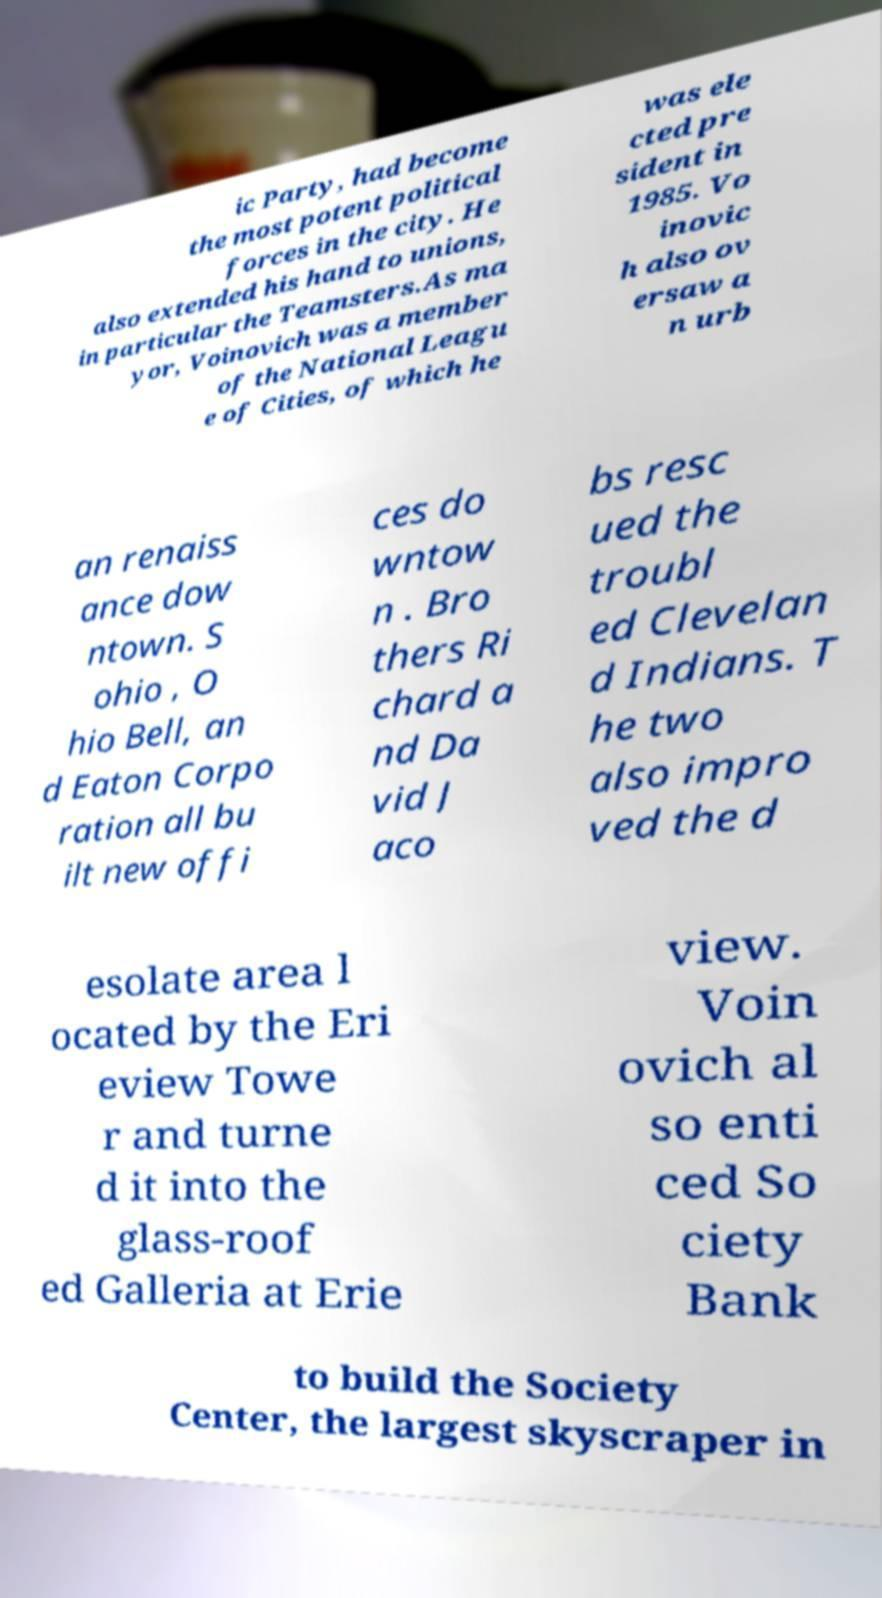There's text embedded in this image that I need extracted. Can you transcribe it verbatim? ic Party, had become the most potent political forces in the city. He also extended his hand to unions, in particular the Teamsters.As ma yor, Voinovich was a member of the National Leagu e of Cities, of which he was ele cted pre sident in 1985. Vo inovic h also ov ersaw a n urb an renaiss ance dow ntown. S ohio , O hio Bell, an d Eaton Corpo ration all bu ilt new offi ces do wntow n . Bro thers Ri chard a nd Da vid J aco bs resc ued the troubl ed Clevelan d Indians. T he two also impro ved the d esolate area l ocated by the Eri eview Towe r and turne d it into the glass-roof ed Galleria at Erie view. Voin ovich al so enti ced So ciety Bank to build the Society Center, the largest skyscraper in 